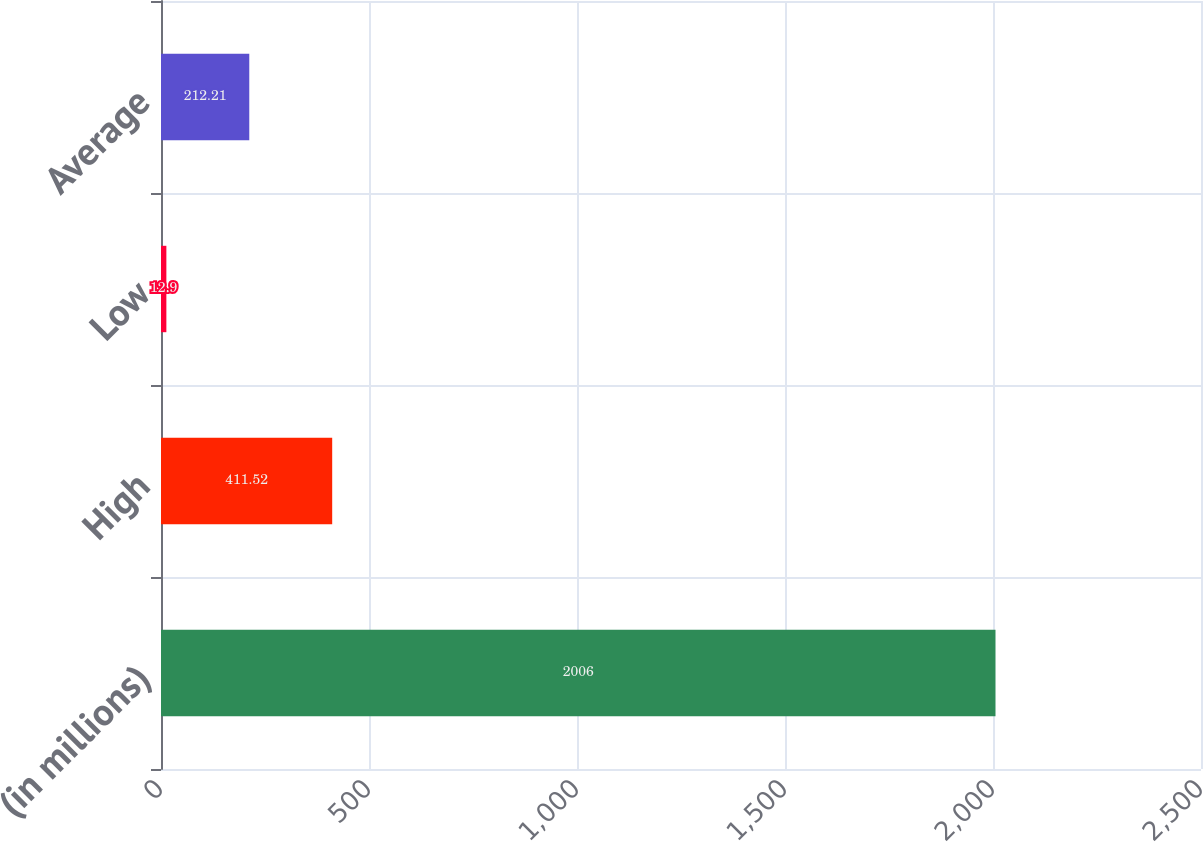Convert chart to OTSL. <chart><loc_0><loc_0><loc_500><loc_500><bar_chart><fcel>(in millions)<fcel>High<fcel>Low<fcel>Average<nl><fcel>2006<fcel>411.52<fcel>12.9<fcel>212.21<nl></chart> 